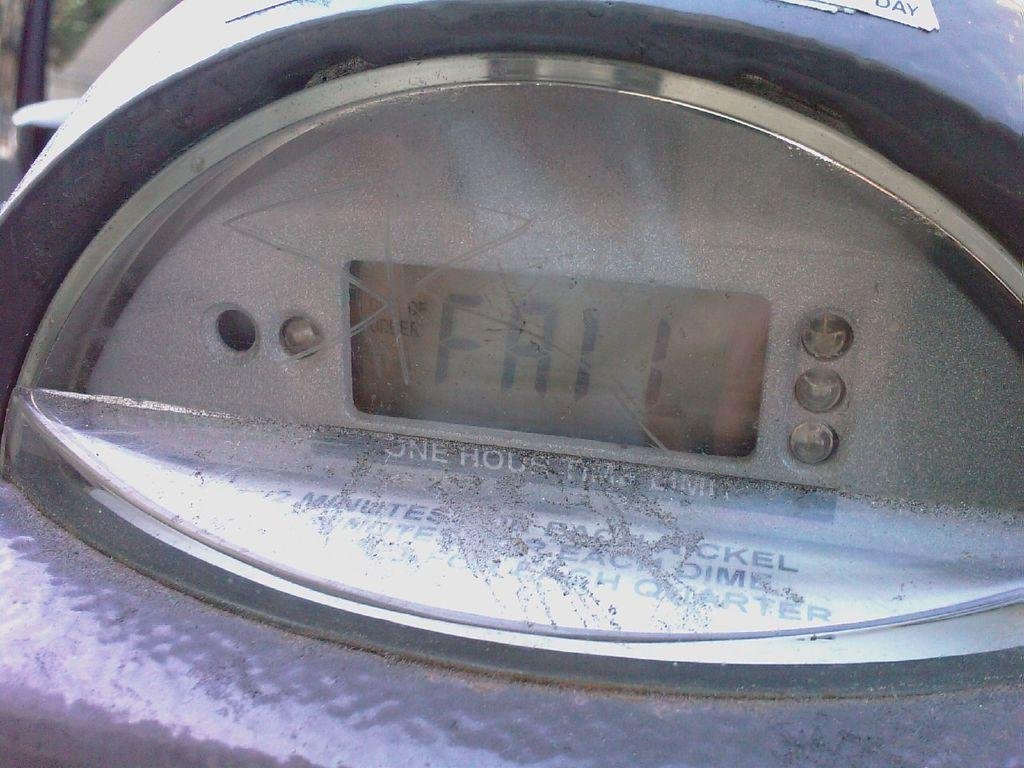<image>
Summarize the visual content of the image. A parking meter's display has the word "fail" on it. 